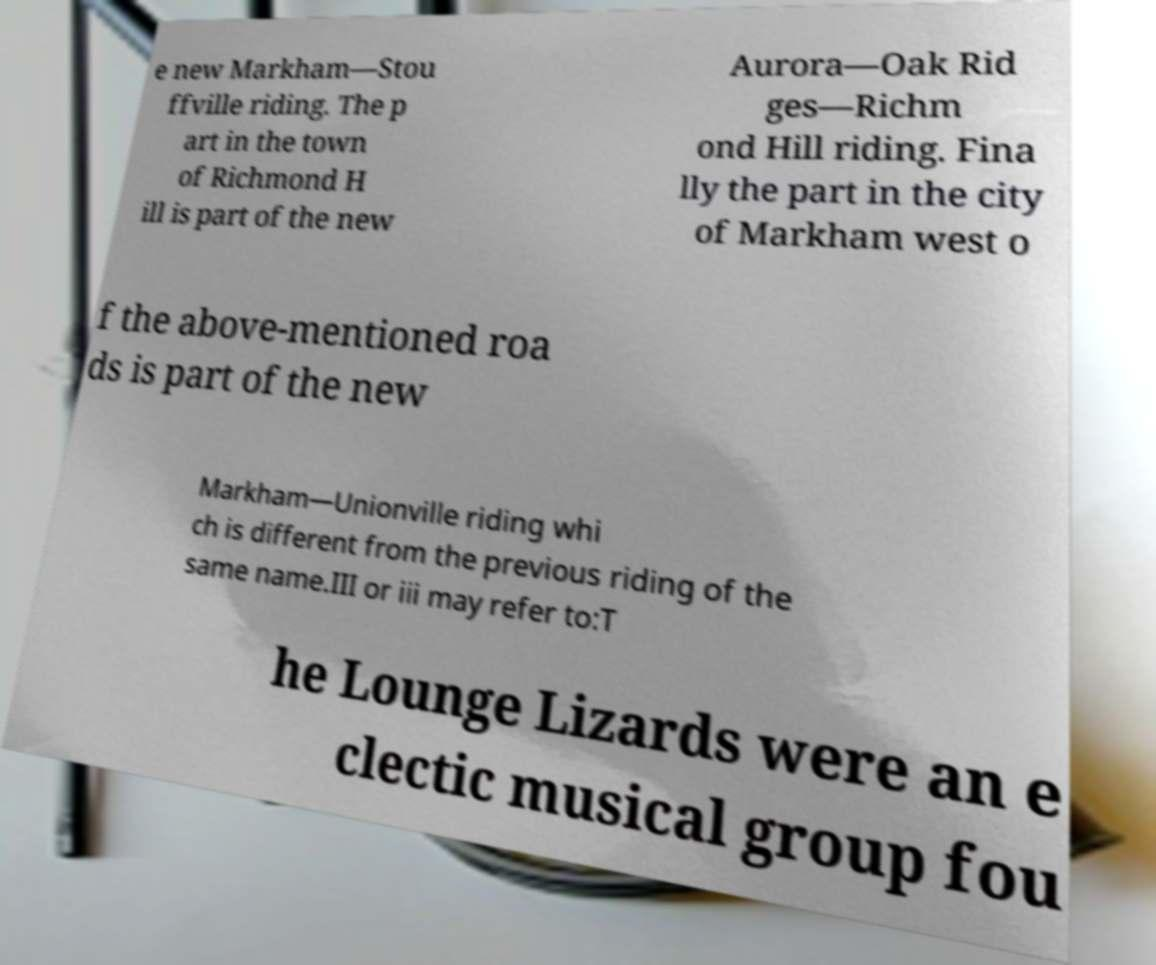Could you extract and type out the text from this image? e new Markham—Stou ffville riding. The p art in the town of Richmond H ill is part of the new Aurora—Oak Rid ges—Richm ond Hill riding. Fina lly the part in the city of Markham west o f the above-mentioned roa ds is part of the new Markham—Unionville riding whi ch is different from the previous riding of the same name.III or iii may refer to:T he Lounge Lizards were an e clectic musical group fou 